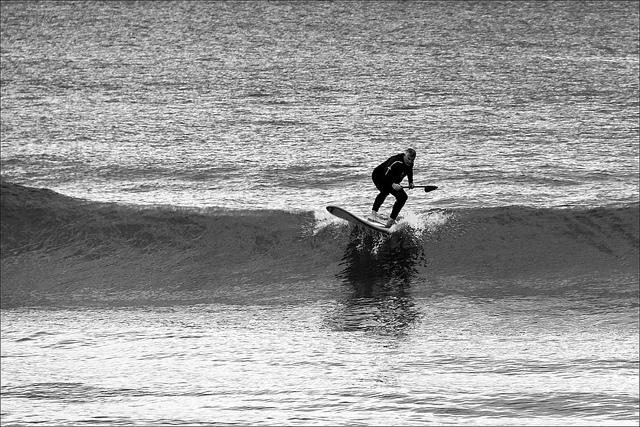Is he walking on water?
Quick response, please. No. Is this guy fishing?
Write a very short answer. No. What is he holding onto?
Write a very short answer. Paddle. Is the picture in black and white?
Answer briefly. Yes. 